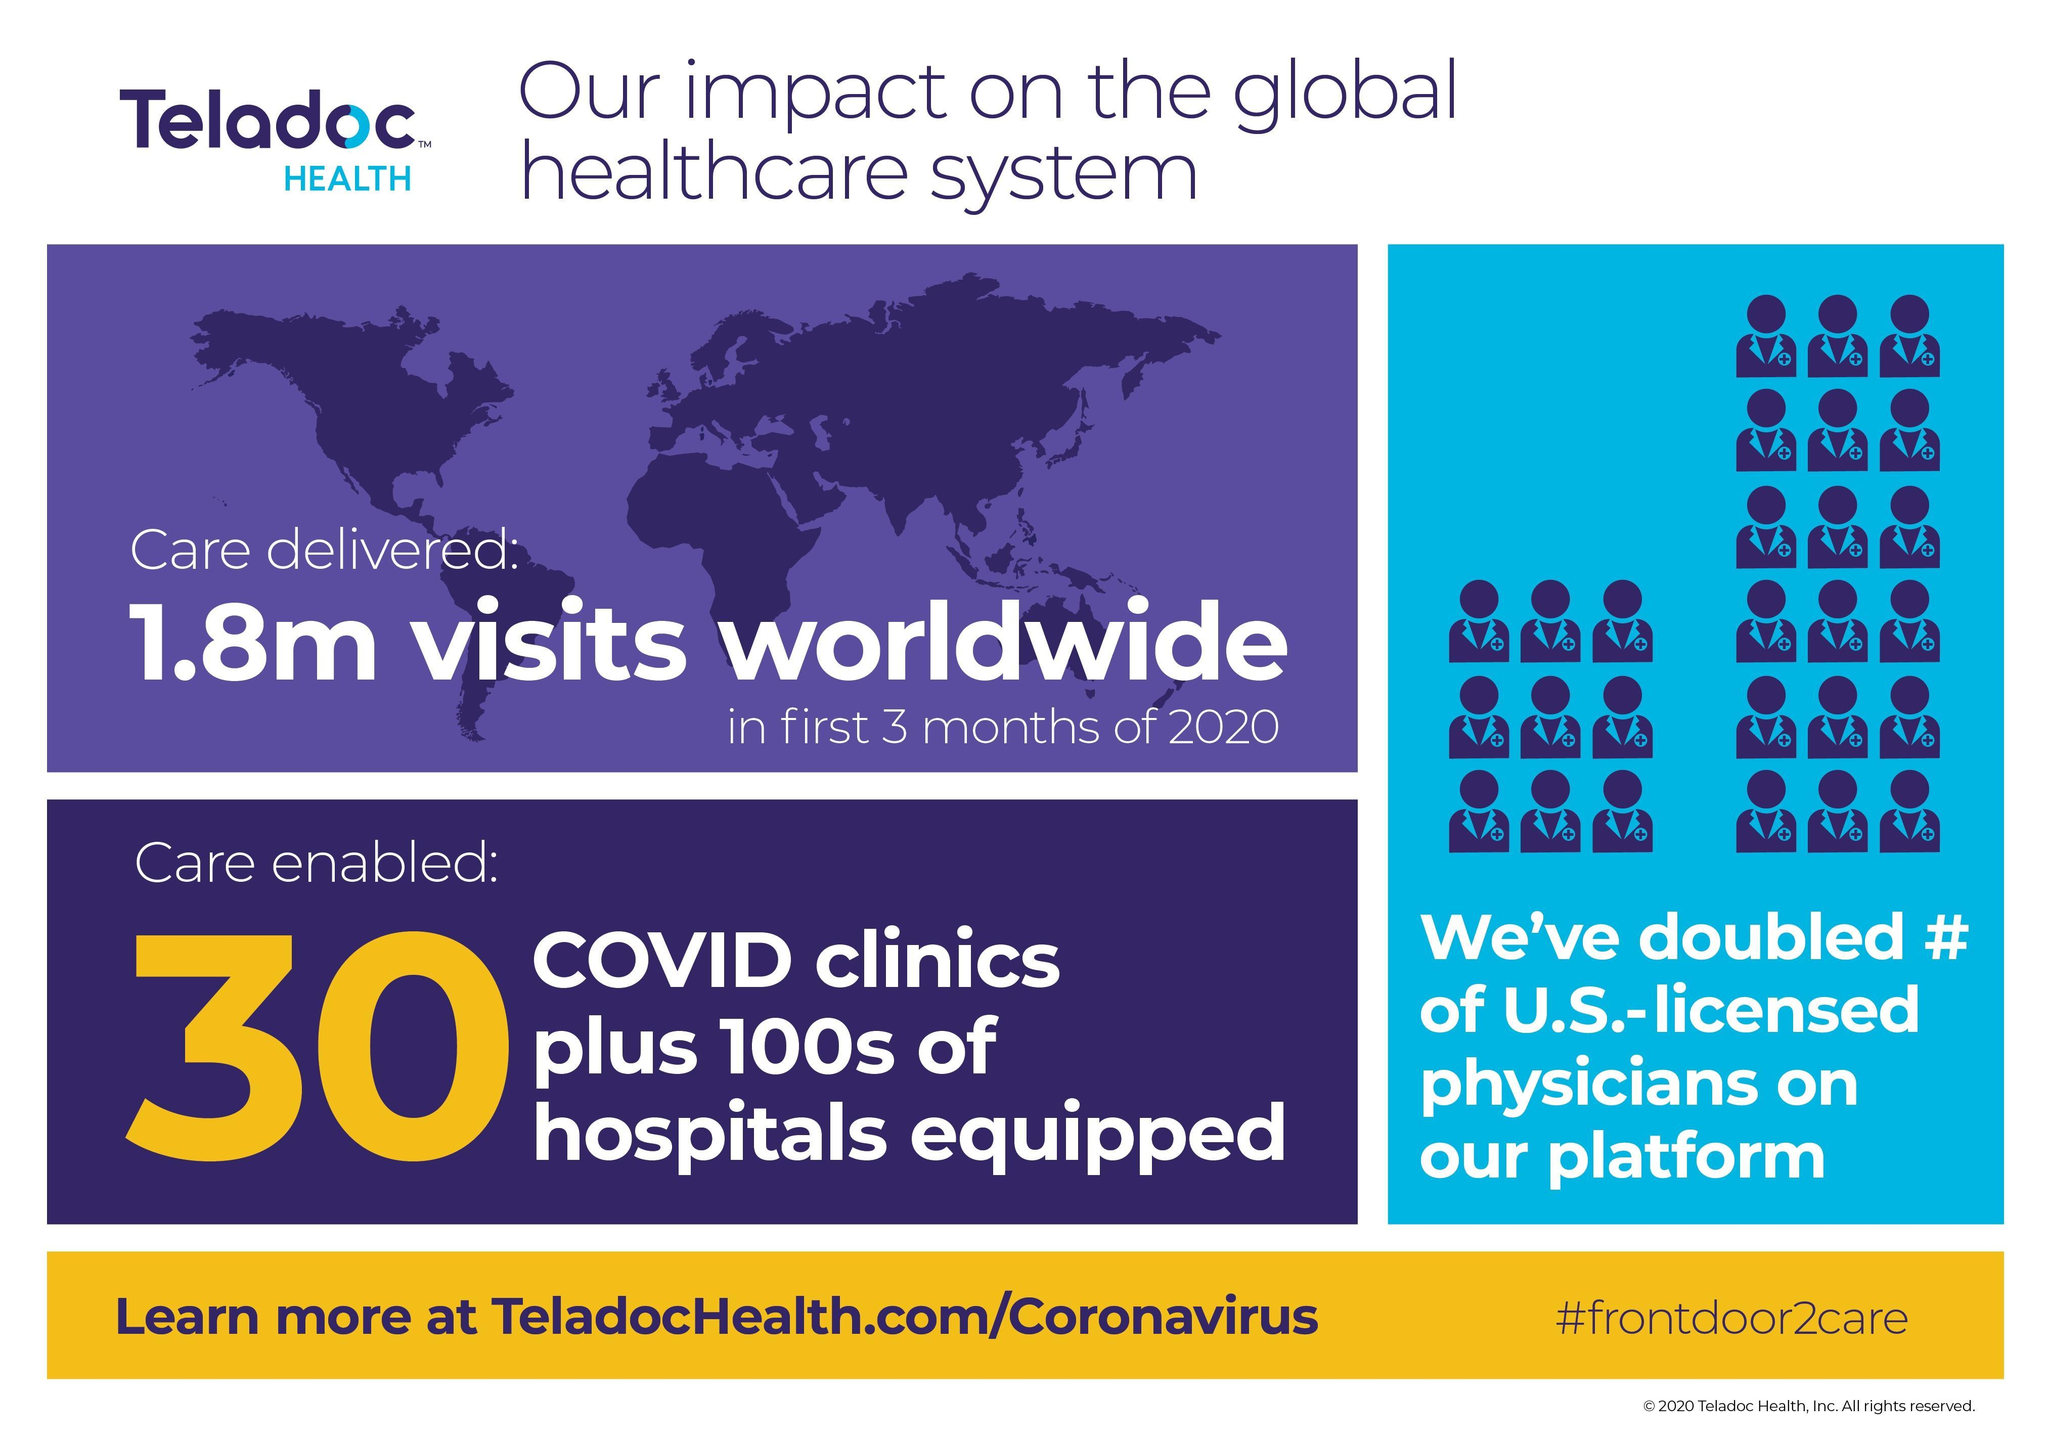How many icons of people are shown in the infographic?
Answer the question with a short phrase. 27 What is the hashtag mentioned? #frontdoor2care 